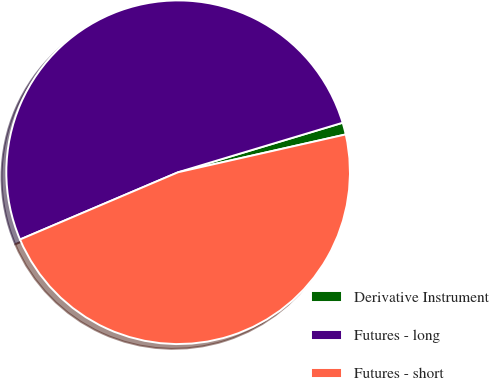<chart> <loc_0><loc_0><loc_500><loc_500><pie_chart><fcel>Derivative Instrument<fcel>Futures - long<fcel>Futures - short<nl><fcel>1.12%<fcel>51.75%<fcel>47.13%<nl></chart> 